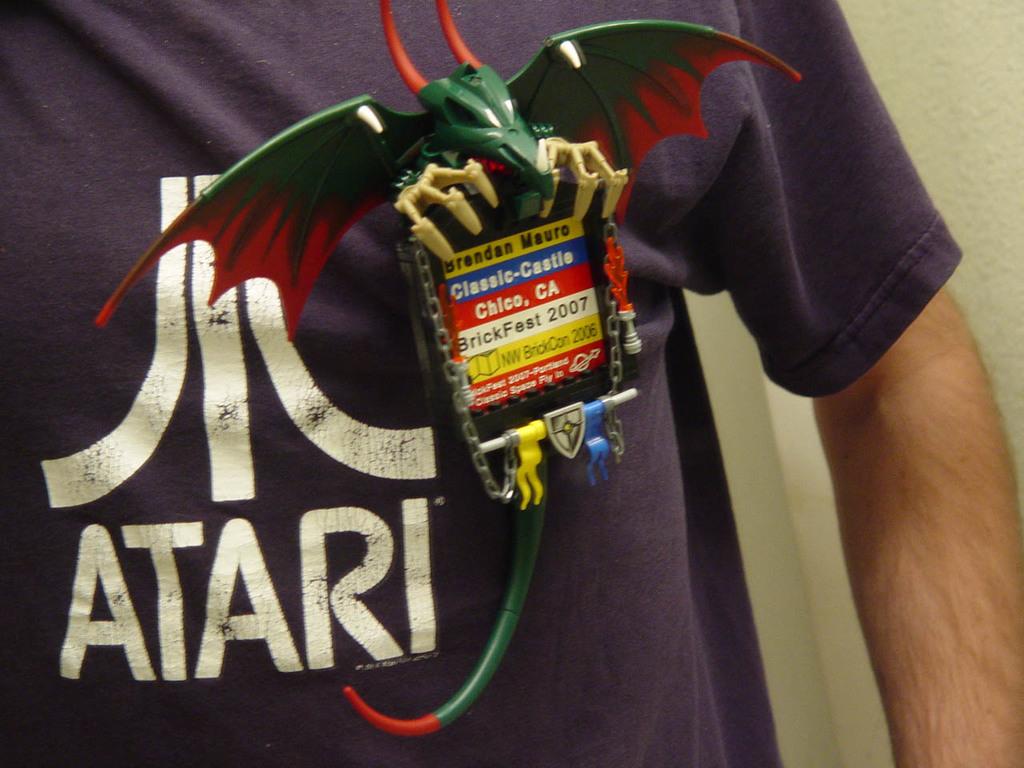What's written on the shirt?
Make the answer very short. Atari. What year is written on his tag?
Your response must be concise. 2007. 